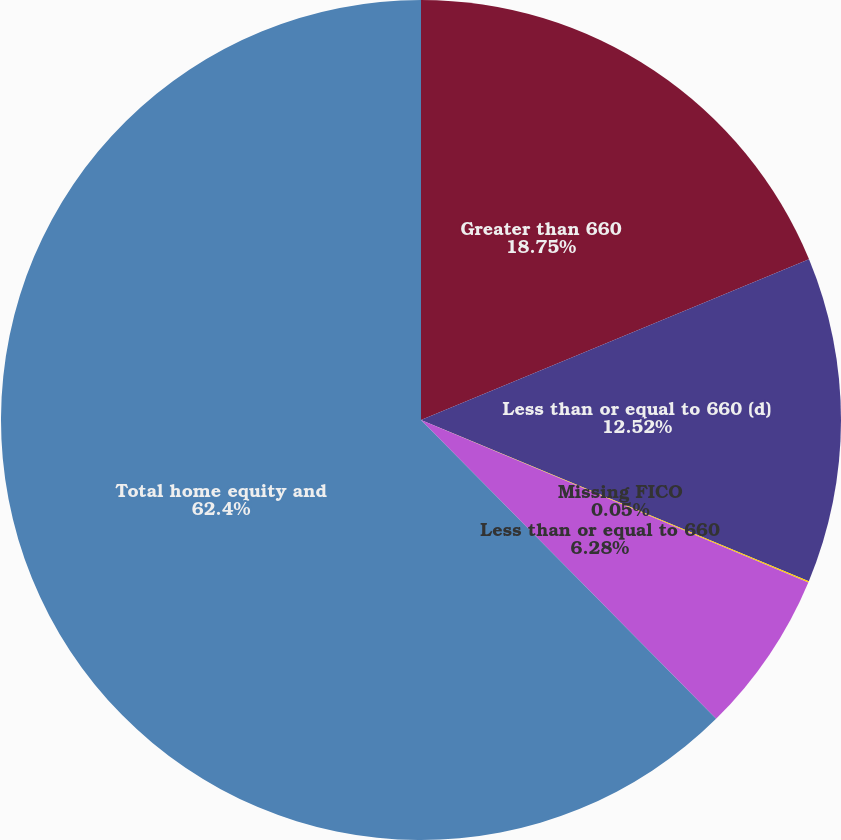<chart> <loc_0><loc_0><loc_500><loc_500><pie_chart><fcel>Greater than 660<fcel>Less than or equal to 660 (d)<fcel>Missing FICO<fcel>Less than or equal to 660<fcel>Total home equity and<nl><fcel>18.75%<fcel>12.52%<fcel>0.05%<fcel>6.28%<fcel>62.4%<nl></chart> 